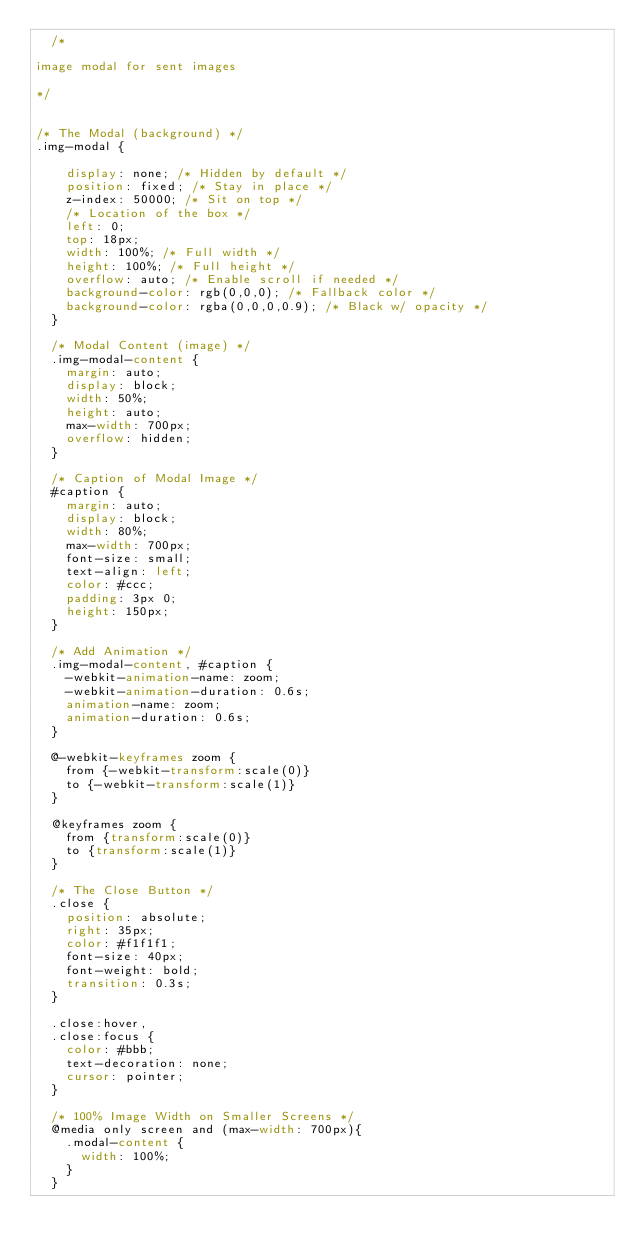Convert code to text. <code><loc_0><loc_0><loc_500><loc_500><_CSS_>  /*

image modal for sent images

*/


/* The Modal (background) */
.img-modal {

    display: none; /* Hidden by default */
    position: fixed; /* Stay in place */
    z-index: 50000; /* Sit on top */
    /* Location of the box */
    left: 0;
    top: 18px;
    width: 100%; /* Full width */
    height: 100%; /* Full height */
    overflow: auto; /* Enable scroll if needed */
    background-color: rgb(0,0,0); /* Fallback color */
    background-color: rgba(0,0,0,0.9); /* Black w/ opacity */
  }
  
  /* Modal Content (image) */
  .img-modal-content {
    margin: auto;
    display: block;
    width: 50%;
    height: auto;
    max-width: 700px;
    overflow: hidden;
  }
  
  /* Caption of Modal Image */
  #caption {
    margin: auto;
    display: block;
    width: 80%;
    max-width: 700px;
    font-size: small;
    text-align: left;
    color: #ccc;
    padding: 3px 0;
    height: 150px;
  }
  
  /* Add Animation */
  .img-modal-content, #caption {  
    -webkit-animation-name: zoom;
    -webkit-animation-duration: 0.6s;
    animation-name: zoom;
    animation-duration: 0.6s;
  }
  
  @-webkit-keyframes zoom {
    from {-webkit-transform:scale(0)} 
    to {-webkit-transform:scale(1)}
  }
  
  @keyframes zoom {
    from {transform:scale(0)} 
    to {transform:scale(1)}
  }
  
  /* The Close Button */
  .close {
    position: absolute;
    right: 35px;
    color: #f1f1f1;
    font-size: 40px;
    font-weight: bold;
    transition: 0.3s;
  }
  
  .close:hover,
  .close:focus {
    color: #bbb;
    text-decoration: none;
    cursor: pointer;
  }
  
  /* 100% Image Width on Smaller Screens */
  @media only screen and (max-width: 700px){
    .modal-content {
      width: 100%;
    }
  }</code> 